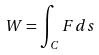<formula> <loc_0><loc_0><loc_500><loc_500>W = \int _ { C } F d s</formula> 